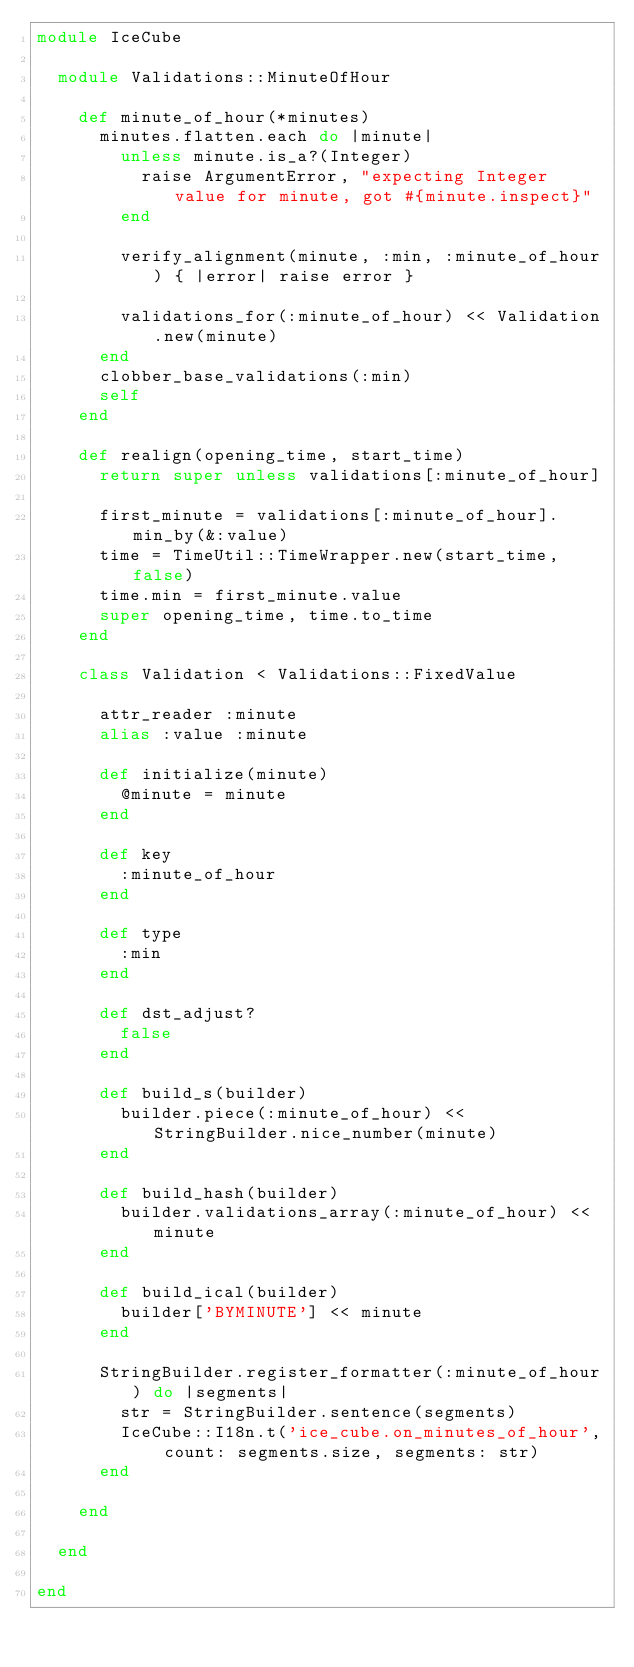Convert code to text. <code><loc_0><loc_0><loc_500><loc_500><_Ruby_>module IceCube

  module Validations::MinuteOfHour

    def minute_of_hour(*minutes)
      minutes.flatten.each do |minute|
        unless minute.is_a?(Integer)
          raise ArgumentError, "expecting Integer value for minute, got #{minute.inspect}"
        end

        verify_alignment(minute, :min, :minute_of_hour) { |error| raise error }

        validations_for(:minute_of_hour) << Validation.new(minute)
      end
      clobber_base_validations(:min)
      self
    end

    def realign(opening_time, start_time)
      return super unless validations[:minute_of_hour]

      first_minute = validations[:minute_of_hour].min_by(&:value)
      time = TimeUtil::TimeWrapper.new(start_time, false)
      time.min = first_minute.value
      super opening_time, time.to_time
    end

    class Validation < Validations::FixedValue

      attr_reader :minute
      alias :value :minute

      def initialize(minute)
        @minute = minute
      end

      def key
        :minute_of_hour
      end

      def type
        :min
      end

      def dst_adjust?
        false
      end

      def build_s(builder)
        builder.piece(:minute_of_hour) << StringBuilder.nice_number(minute)
      end

      def build_hash(builder)
        builder.validations_array(:minute_of_hour) << minute
      end

      def build_ical(builder)
        builder['BYMINUTE'] << minute
      end

      StringBuilder.register_formatter(:minute_of_hour) do |segments|
        str = StringBuilder.sentence(segments)
        IceCube::I18n.t('ice_cube.on_minutes_of_hour', count: segments.size, segments: str)
      end

    end

  end

end
</code> 